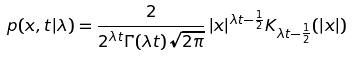Convert formula to latex. <formula><loc_0><loc_0><loc_500><loc_500>p ( x , t | \lambda ) = \frac { 2 } { 2 ^ { \lambda t } \Gamma ( \lambda t ) \sqrt { 2 \pi } } \, | x | ^ { \lambda t - \frac { 1 } { 2 } } K _ { \lambda t - \frac { 1 } { 2 } } ( | x | )</formula> 